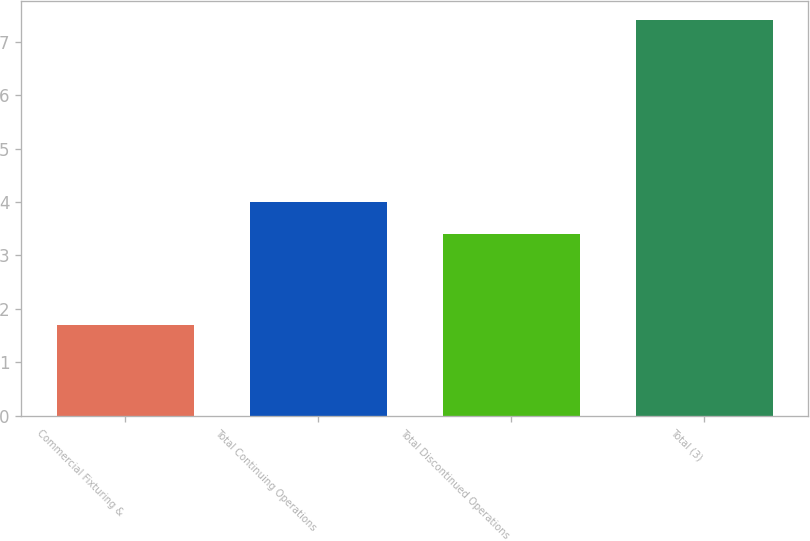Convert chart to OTSL. <chart><loc_0><loc_0><loc_500><loc_500><bar_chart><fcel>Commercial Fixturing &<fcel>Total Continuing Operations<fcel>Total Discontinued Operations<fcel>Total (3)<nl><fcel>1.7<fcel>4<fcel>3.4<fcel>7.4<nl></chart> 